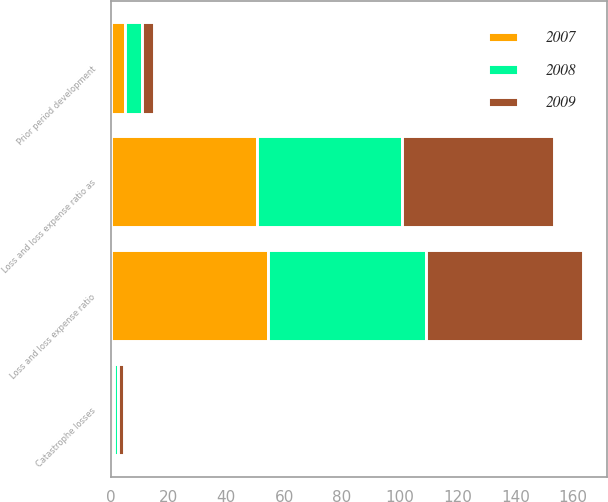Convert chart to OTSL. <chart><loc_0><loc_0><loc_500><loc_500><stacked_bar_chart><ecel><fcel>Loss and loss expense ratio as<fcel>Catastrophe losses<fcel>Prior period development<fcel>Loss and loss expense ratio<nl><fcel>2007<fcel>50.5<fcel>1<fcel>5<fcel>54.5<nl><fcel>2008<fcel>50.4<fcel>1.6<fcel>5.7<fcel>54.5<nl><fcel>2009<fcel>52.4<fcel>2.1<fcel>4.1<fcel>54.4<nl></chart> 